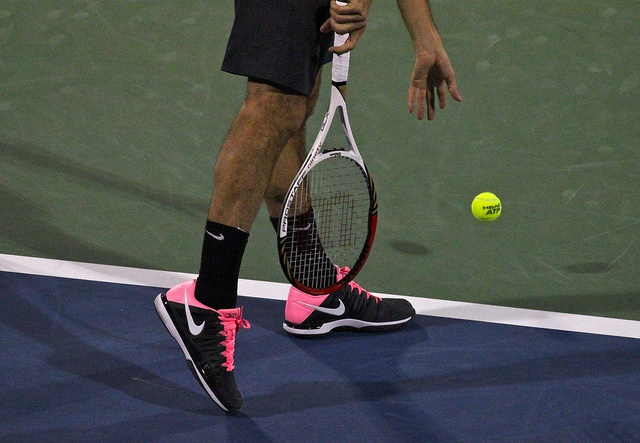Describe the objects in this image and their specific colors. I can see people in darkgreen, black, maroon, and gray tones, tennis racket in darkgreen, gray, black, and darkgray tones, and sports ball in darkgreen, yellow, olive, and khaki tones in this image. 